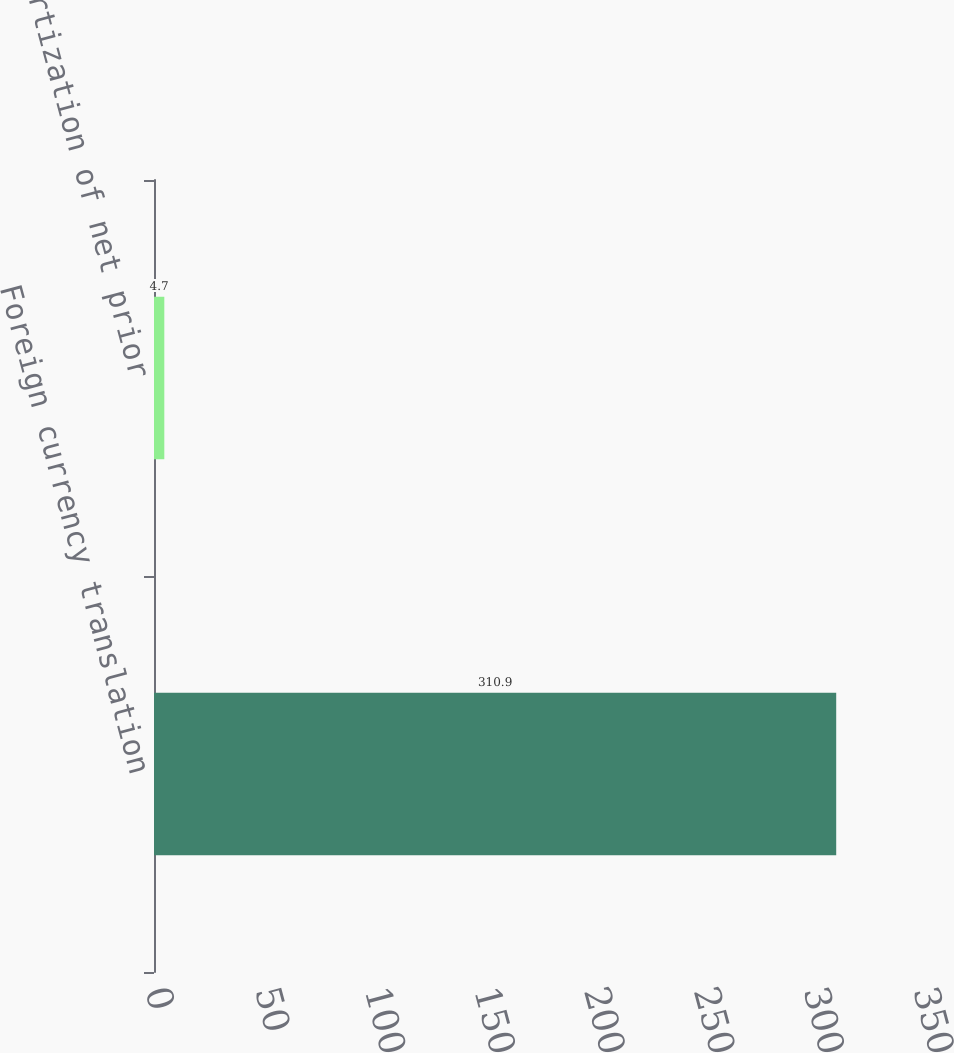Convert chart to OTSL. <chart><loc_0><loc_0><loc_500><loc_500><bar_chart><fcel>Foreign currency translation<fcel>Amortization of net prior<nl><fcel>310.9<fcel>4.7<nl></chart> 